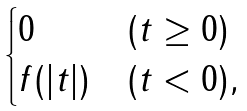Convert formula to latex. <formula><loc_0><loc_0><loc_500><loc_500>\begin{cases} 0 & ( t \geq 0 ) \\ f ( | t | ) & ( t < 0 ) , \end{cases}</formula> 